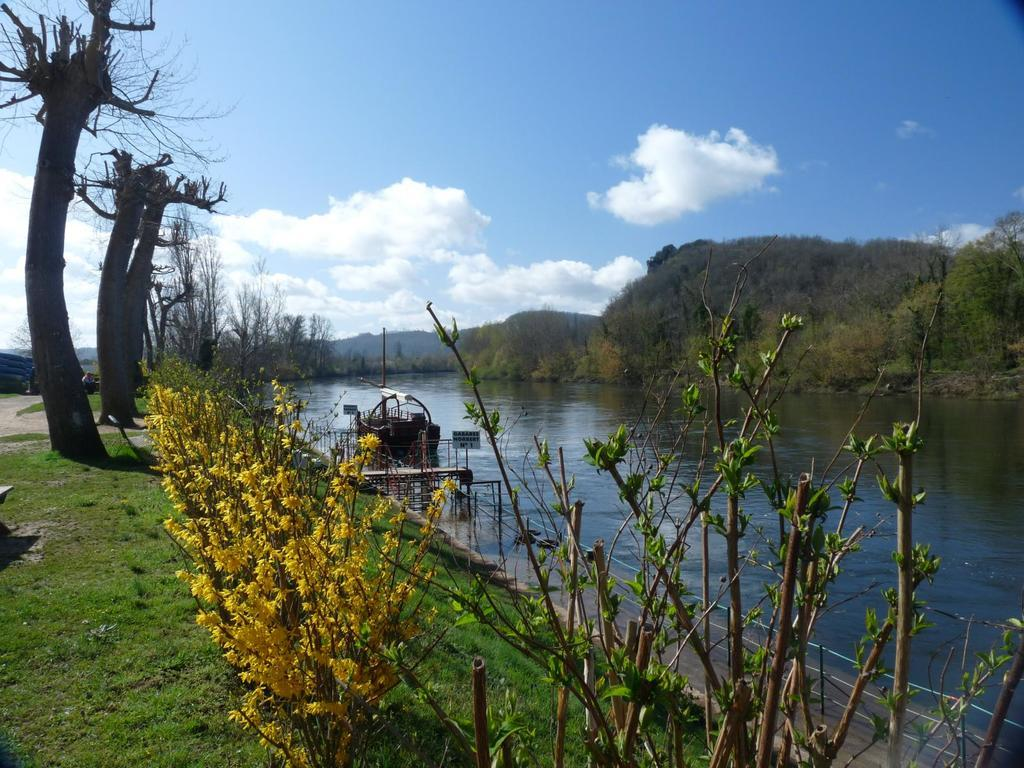What type of terrain is visible in the image? Ground, grass, and trees are visible in the image. What type of vegetation can be seen in the image? Dry trees and plants are present in the image. What natural features are visible in the distance? Mountains and water are visible in the image. How is the water being traversed in the image? There is a path above the water, and a boat is present in the image. What is visible in the sky in the image? The sky is visible in the image, with clouds present. Where is the rabbit hiding in the image? There is no rabbit present in the image. How many drops of water can be seen falling from the clouds in the image? There is no rain or water droplets visible falling from the clouds in the image. 